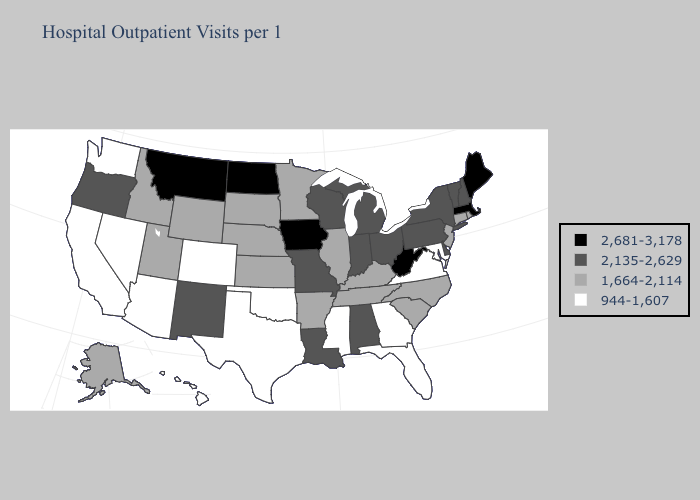What is the value of Vermont?
Be succinct. 2,135-2,629. Does Maryland have the highest value in the USA?
Short answer required. No. Among the states that border California , does Nevada have the highest value?
Concise answer only. No. Does Minnesota have a lower value than Arkansas?
Give a very brief answer. No. Name the states that have a value in the range 2,681-3,178?
Concise answer only. Iowa, Maine, Massachusetts, Montana, North Dakota, West Virginia. Which states have the highest value in the USA?
Keep it brief. Iowa, Maine, Massachusetts, Montana, North Dakota, West Virginia. What is the value of North Carolina?
Write a very short answer. 1,664-2,114. Does Massachusetts have the highest value in the Northeast?
Answer briefly. Yes. Does Delaware have a higher value than Minnesota?
Be succinct. Yes. Name the states that have a value in the range 944-1,607?
Concise answer only. Arizona, California, Colorado, Florida, Georgia, Hawaii, Maryland, Mississippi, Nevada, Oklahoma, Texas, Virginia, Washington. What is the lowest value in the USA?
Short answer required. 944-1,607. What is the lowest value in the USA?
Be succinct. 944-1,607. Does Delaware have a lower value than West Virginia?
Give a very brief answer. Yes. What is the lowest value in the USA?
Short answer required. 944-1,607. Name the states that have a value in the range 2,681-3,178?
Write a very short answer. Iowa, Maine, Massachusetts, Montana, North Dakota, West Virginia. 